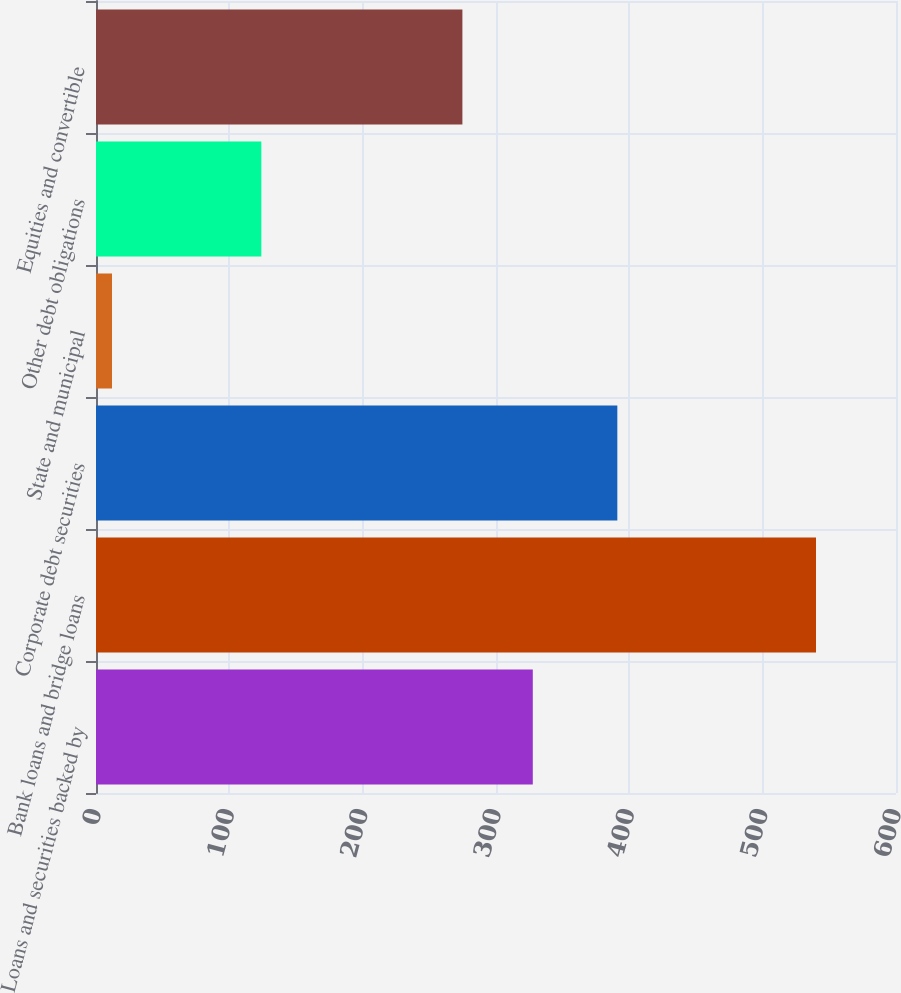Convert chart. <chart><loc_0><loc_0><loc_500><loc_500><bar_chart><fcel>Loans and securities backed by<fcel>Bank loans and bridge loans<fcel>Corporate debt securities<fcel>State and municipal<fcel>Other debt obligations<fcel>Equities and convertible<nl><fcel>327.6<fcel>540<fcel>391<fcel>12<fcel>124<fcel>274.8<nl></chart> 